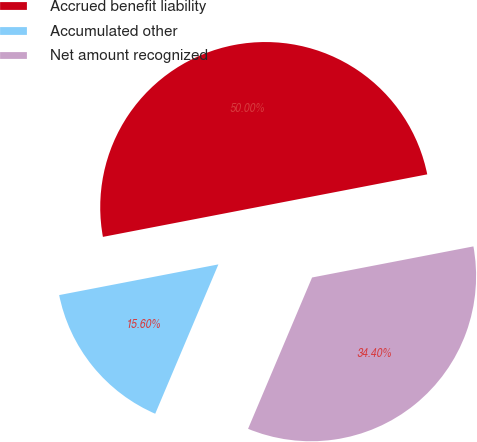Convert chart to OTSL. <chart><loc_0><loc_0><loc_500><loc_500><pie_chart><fcel>Accrued benefit liability<fcel>Accumulated other<fcel>Net amount recognized<nl><fcel>50.0%<fcel>15.6%<fcel>34.4%<nl></chart> 